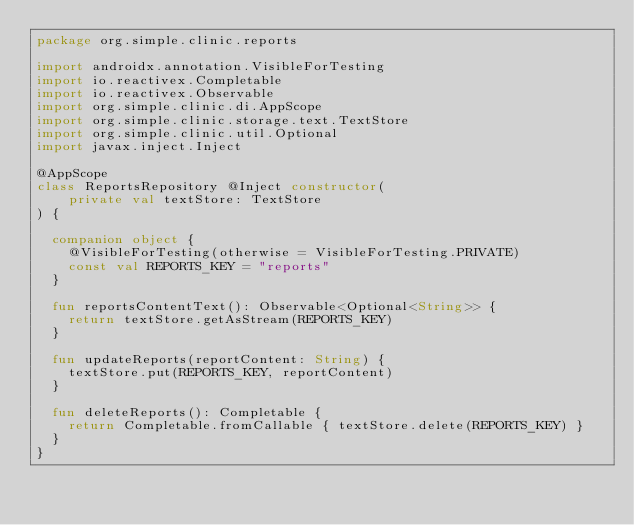Convert code to text. <code><loc_0><loc_0><loc_500><loc_500><_Kotlin_>package org.simple.clinic.reports

import androidx.annotation.VisibleForTesting
import io.reactivex.Completable
import io.reactivex.Observable
import org.simple.clinic.di.AppScope
import org.simple.clinic.storage.text.TextStore
import org.simple.clinic.util.Optional
import javax.inject.Inject

@AppScope
class ReportsRepository @Inject constructor(
    private val textStore: TextStore
) {

  companion object {
    @VisibleForTesting(otherwise = VisibleForTesting.PRIVATE)
    const val REPORTS_KEY = "reports"
  }

  fun reportsContentText(): Observable<Optional<String>> {
    return textStore.getAsStream(REPORTS_KEY)
  }

  fun updateReports(reportContent: String) {
    textStore.put(REPORTS_KEY, reportContent)
  }

  fun deleteReports(): Completable {
    return Completable.fromCallable { textStore.delete(REPORTS_KEY) }
  }
}
</code> 